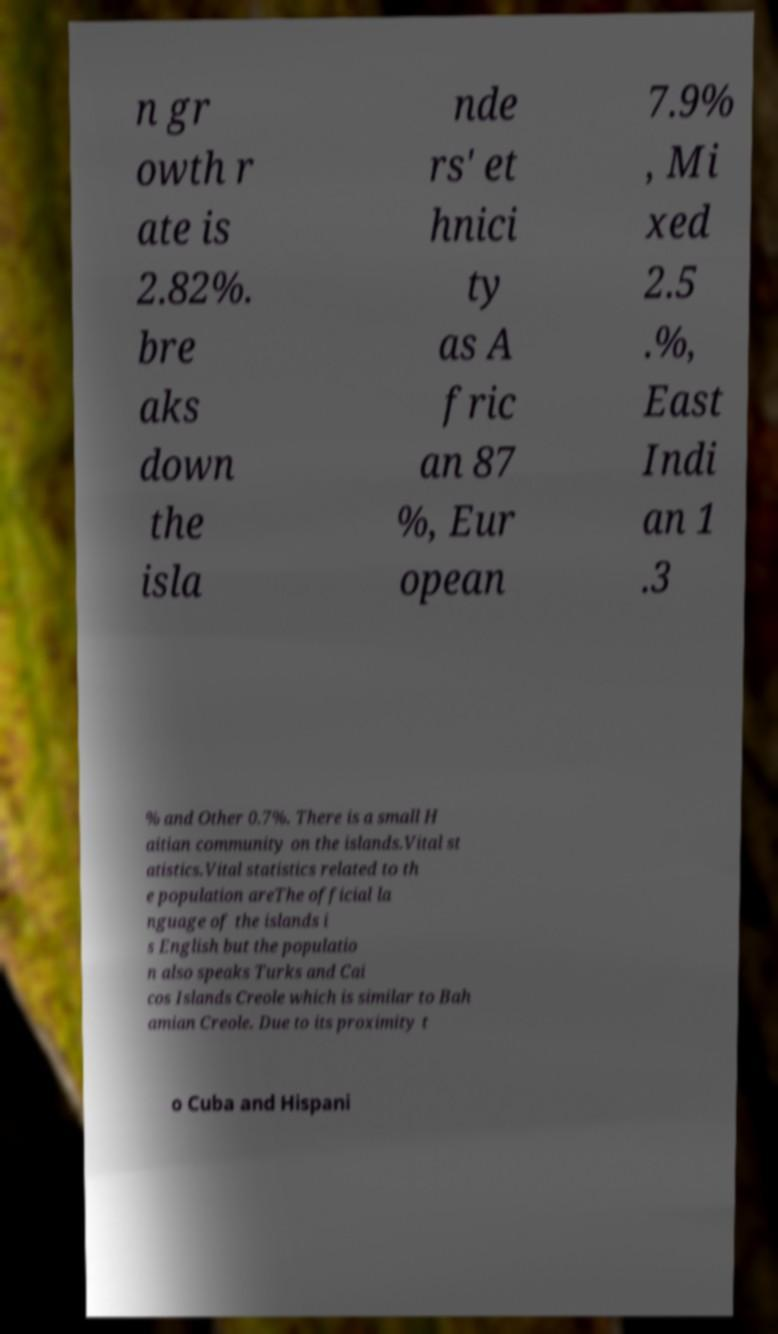Can you accurately transcribe the text from the provided image for me? n gr owth r ate is 2.82%. bre aks down the isla nde rs' et hnici ty as A fric an 87 %, Eur opean 7.9% , Mi xed 2.5 .%, East Indi an 1 .3 % and Other 0.7%. There is a small H aitian community on the islands.Vital st atistics.Vital statistics related to th e population areThe official la nguage of the islands i s English but the populatio n also speaks Turks and Cai cos Islands Creole which is similar to Bah amian Creole. Due to its proximity t o Cuba and Hispani 